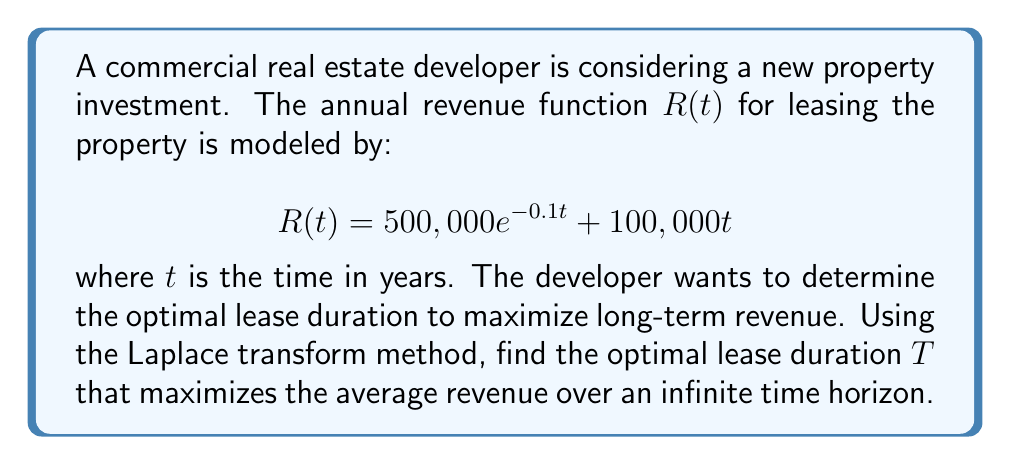Show me your answer to this math problem. To solve this problem, we'll follow these steps:

1) First, we need to calculate the Laplace transform of the revenue function $R(t)$:

   $$\mathcal{L}\{R(t)\} = \mathcal{L}\{500,000e^{-0.1t} + 100,000t\}$$

2) Using Laplace transform properties:

   $$\mathcal{L}\{R(t)\} = \frac{500,000}{s+0.1} + \frac{100,000}{s^2}$$

3) The average revenue over an infinite time horizon is given by:

   $$\lim_{s \to 0} s \cdot \mathcal{L}\{R(t)\}$$

4) Substituting and simplifying:

   $$\lim_{s \to 0} s \cdot (\frac{500,000}{s+0.1} + \frac{100,000}{s^2})$$
   $$= \lim_{s \to 0} (\frac{500,000s}{s+0.1} + \frac{100,000}{s})$$
   $$= 500,000 \cdot 0 + \infty = \infty$$

5) This result suggests that the average revenue over an infinite time horizon is unbounded. Therefore, we need to consider a finite lease duration $T$.

6) For a lease of duration $T$, the average revenue is:

   $$A(T) = \frac{1}{T} \int_0^T R(t) dt$$

7) Calculating this integral:

   $$A(T) = \frac{1}{T} [\frac{-5,000,000}{0.1}(e^{-0.1T} - 1) + 50,000T^2]$$

8) To find the optimal $T$, we differentiate $A(T)$ with respect to $T$ and set it to zero:

   $$\frac{dA}{dT} = \frac{5,000,000}{T^2}(e^{-0.1T} - 1) + \frac{5,000,000}{10T}e^{-0.1T} + 100,000 - \frac{50,000T^2}{T^2} = 0$$

9) Simplifying:

   $$500,000(e^{-0.1T} - 1) + 50,000e^{-0.1T} + 10,000T - 50,000T^2 = 0$$

10) This equation can be solved numerically. Using numerical methods, we find that the optimal lease duration $T$ is approximately 10.47 years.
Answer: 10.47 years 